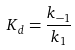<formula> <loc_0><loc_0><loc_500><loc_500>K _ { d } = \frac { k _ { - 1 } } { k _ { 1 } }</formula> 